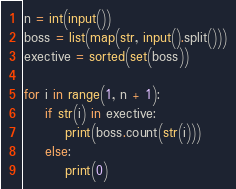Convert code to text. <code><loc_0><loc_0><loc_500><loc_500><_Python_>n = int(input())
boss = list(map(str, input().split()))
exective = sorted(set(boss))

for i in range(1, n + 1):
    if str(i) in exective:
        print(boss.count(str(i)))
    else:
        print(0)</code> 